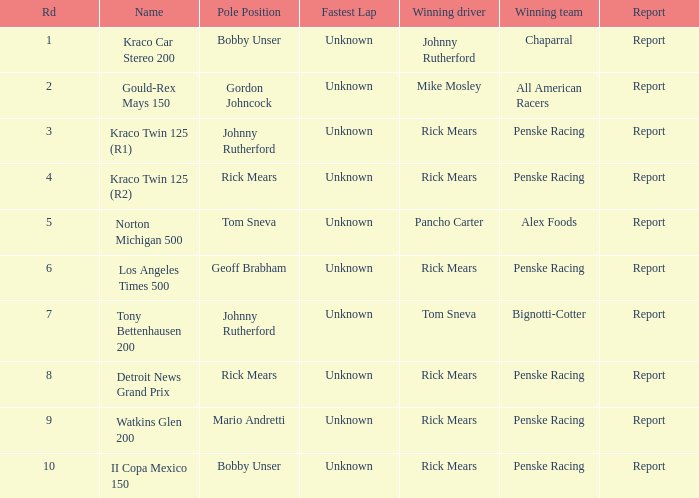In which contests has johnny rutherford achieved victory? Kraco Car Stereo 200. 